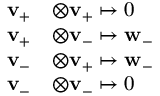<formula> <loc_0><loc_0><loc_500><loc_500>\begin{array} { r l } { v _ { + } } & { \otimes v _ { + } \mapsto 0 } \\ { v _ { + } } & { \otimes v _ { - } \mapsto w _ { - } } \\ { v _ { - } } & { \otimes v _ { + } \mapsto w _ { - } } \\ { v _ { - } } & { \otimes v _ { - } \mapsto 0 } \end{array}</formula> 